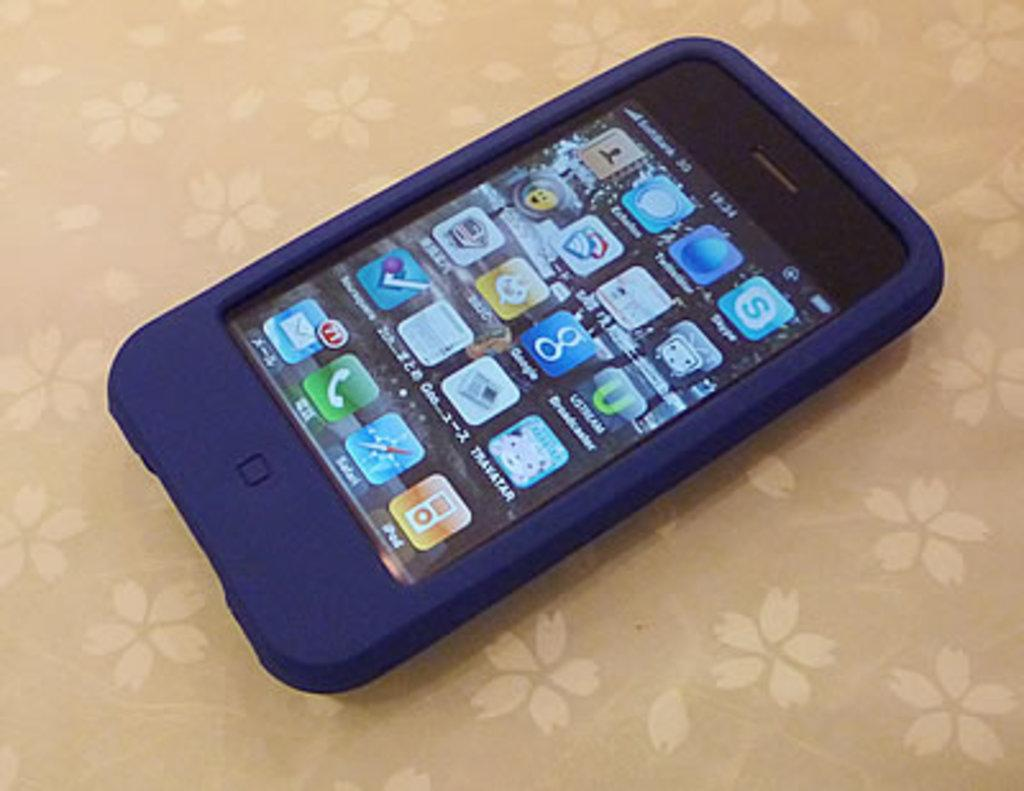<image>
Describe the image concisely. An iPhone covered with a blue case shows the time at 12:24. 